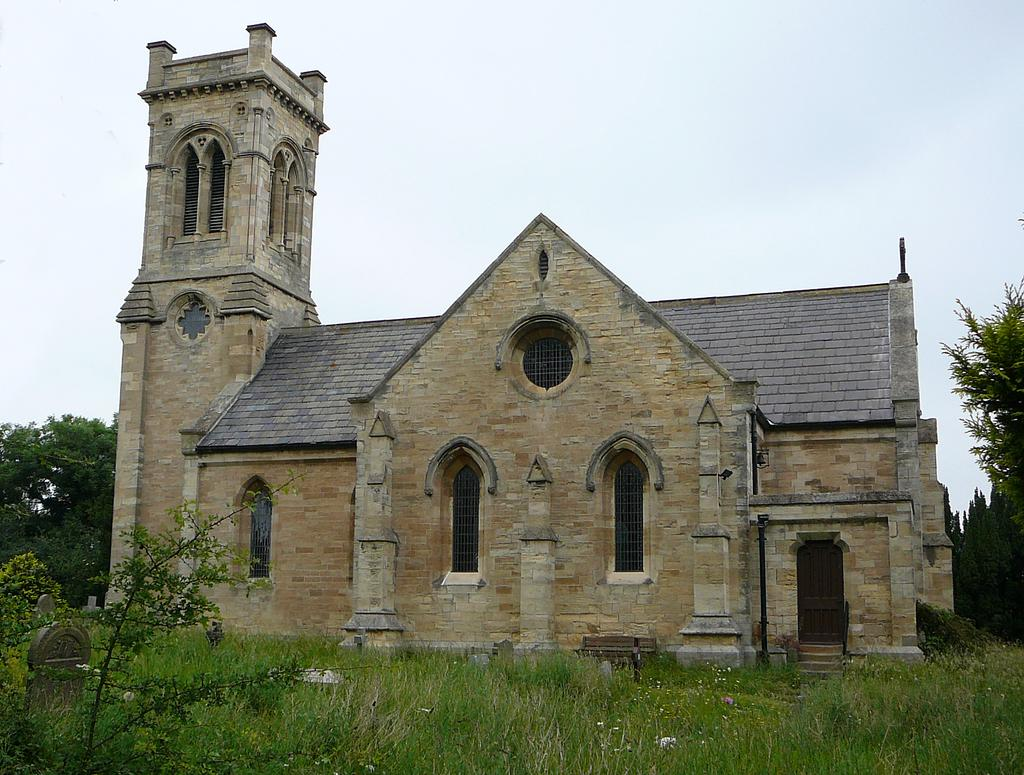What type of vegetation can be seen in the image? There is grass in the image. What other natural elements are present in the image? There are trees in the image. What is visible in the background of the image? The sky is visible in the image. What type of structure can be seen in the image? There is a cream-colored building in the image. What type of stone is being used to build the war in the image? There is no war present in the image, and therefore no stone being used for its construction. 